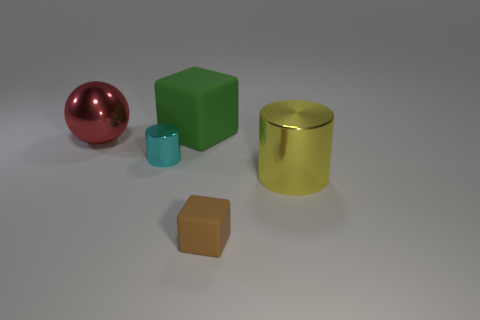Can you infer the size of the space in which these objects are placed? While the precise size of the space can't be determined just by the objects and their arrangement, the shadows suggest that the space is not confined. The objects cast fairly soft shadows which could mean that they're in a moderately open space. However, without additional context, it's difficult to draw a definite conclusion about the size of the space. 